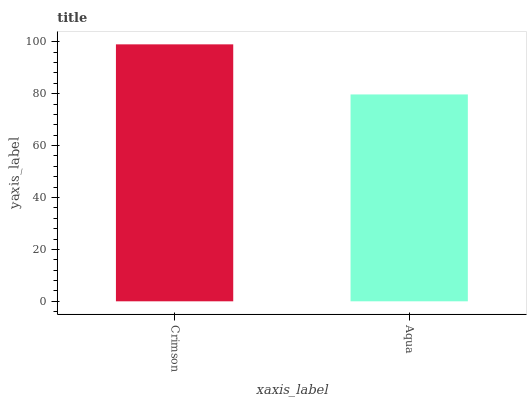Is Aqua the minimum?
Answer yes or no. Yes. Is Crimson the maximum?
Answer yes or no. Yes. Is Aqua the maximum?
Answer yes or no. No. Is Crimson greater than Aqua?
Answer yes or no. Yes. Is Aqua less than Crimson?
Answer yes or no. Yes. Is Aqua greater than Crimson?
Answer yes or no. No. Is Crimson less than Aqua?
Answer yes or no. No. Is Crimson the high median?
Answer yes or no. Yes. Is Aqua the low median?
Answer yes or no. Yes. Is Aqua the high median?
Answer yes or no. No. Is Crimson the low median?
Answer yes or no. No. 